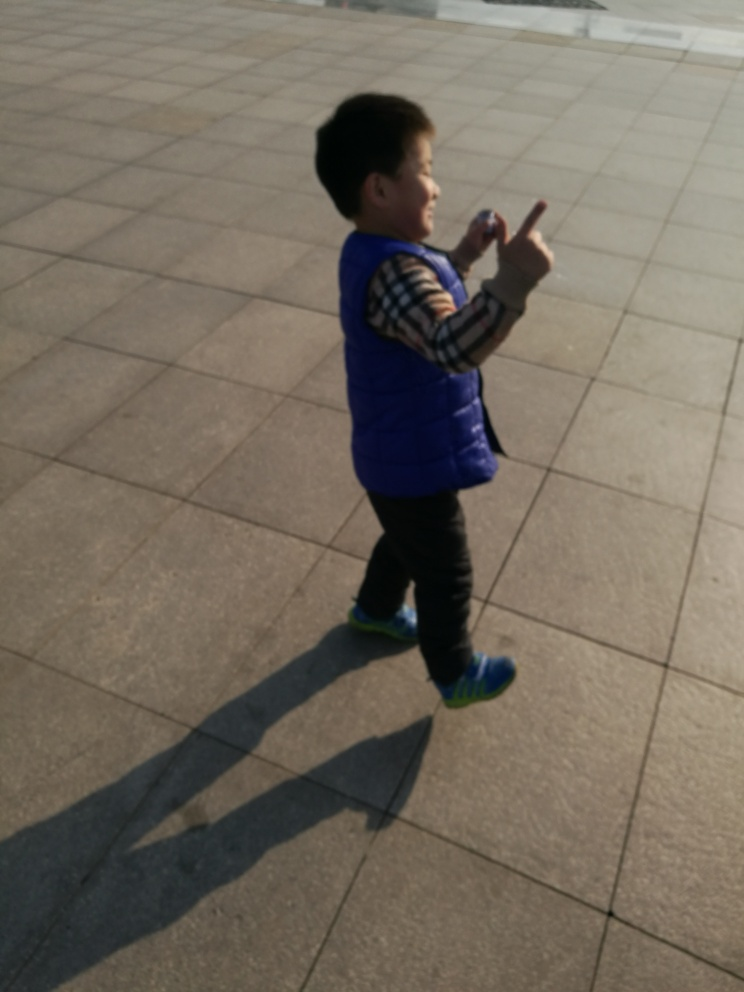Does this scene tell us anything about where it might be located? The wide-open space with no visible trees or natural features, combined with the style of pavement, suggests an urban plaza or a similar public space that could be found in many city centers around the world. 